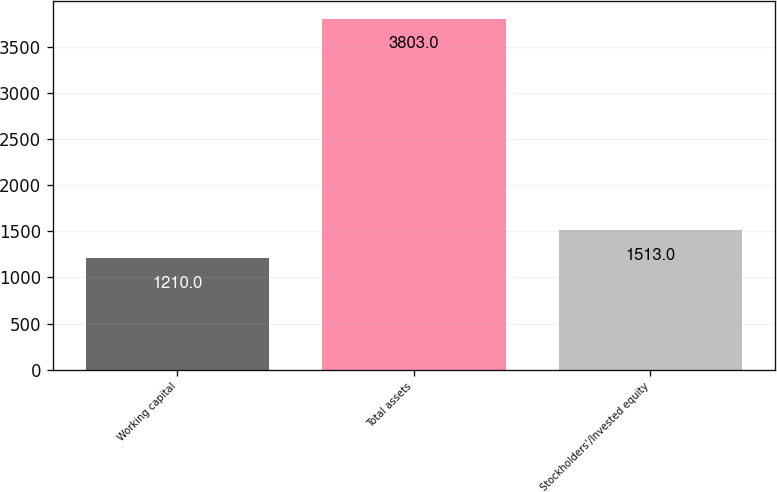Convert chart. <chart><loc_0><loc_0><loc_500><loc_500><bar_chart><fcel>Working capital<fcel>Total assets<fcel>Stockholders'/Invested equity<nl><fcel>1210<fcel>3803<fcel>1513<nl></chart> 